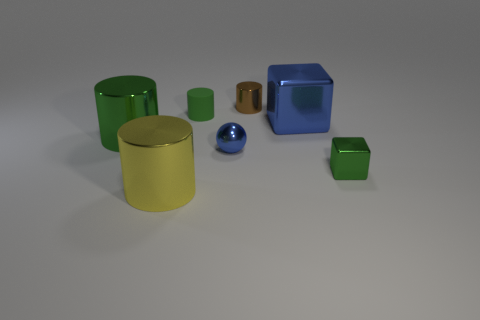How many things are objects that are left of the yellow thing or cylinders in front of the brown cylinder?
Ensure brevity in your answer.  3. The small matte thing has what color?
Offer a very short reply. Green. What number of other tiny yellow spheres are the same material as the sphere?
Your answer should be compact. 0. Are there more small green matte objects than tiny blue rubber cubes?
Make the answer very short. Yes. How many metallic objects are behind the green metal thing that is behind the green cube?
Offer a terse response. 2. What number of things are green objects that are on the left side of the ball or rubber spheres?
Ensure brevity in your answer.  2. Are there any big objects of the same shape as the small green metallic thing?
Keep it short and to the point. Yes. There is a large thing in front of the ball on the right side of the green metal cylinder; what is its shape?
Keep it short and to the point. Cylinder. How many spheres are small blue objects or yellow metallic objects?
Make the answer very short. 1. What is the material of the small object that is the same color as the matte cylinder?
Offer a terse response. Metal. 